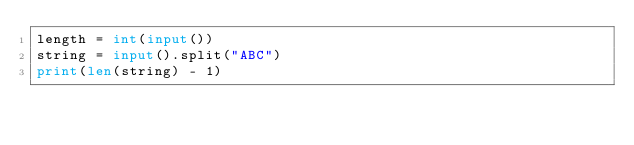Convert code to text. <code><loc_0><loc_0><loc_500><loc_500><_Python_>length = int(input())
string = input().split("ABC")
print(len(string) - 1)</code> 